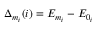Convert formula to latex. <formula><loc_0><loc_0><loc_500><loc_500>\Delta _ { m _ { i } } ( i ) = E _ { m _ { i } } - E _ { 0 _ { i } }</formula> 